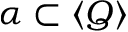<formula> <loc_0><loc_0><loc_500><loc_500>\alpha \subset \langle Q \rangle</formula> 